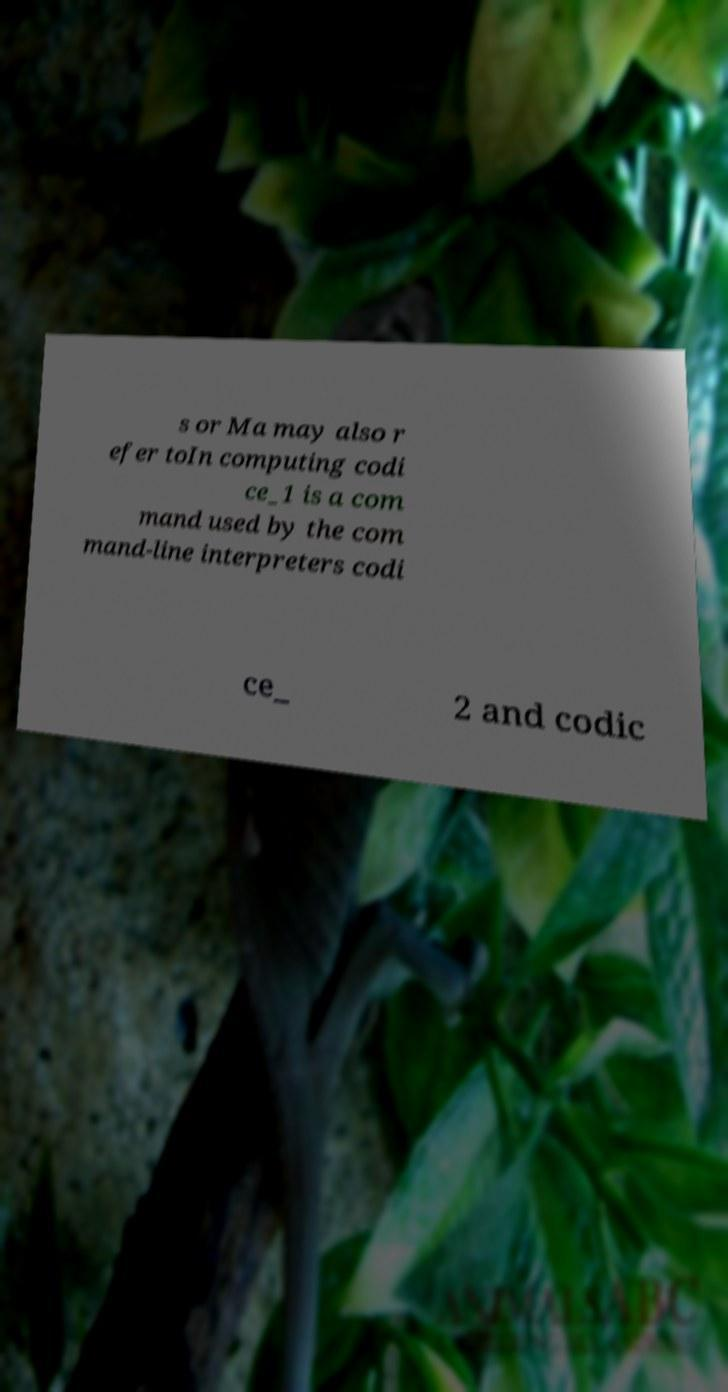There's text embedded in this image that I need extracted. Can you transcribe it verbatim? s or Ma may also r efer toIn computing codi ce_1 is a com mand used by the com mand-line interpreters codi ce_ 2 and codic 